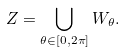<formula> <loc_0><loc_0><loc_500><loc_500>Z = \bigcup _ { \theta \in [ 0 , 2 \pi ] } W _ { \theta } .</formula> 